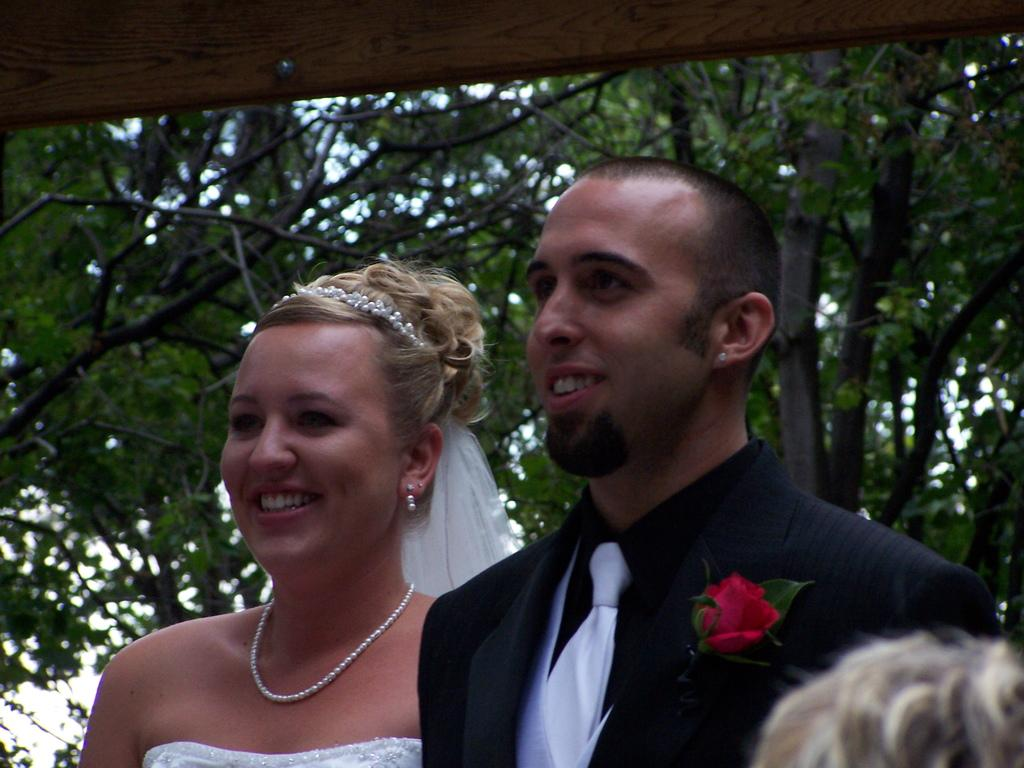What is located in the foreground of the image? There are people in the foreground of the image. What can be seen in the background of the image? There are trees in the background of the image. What is the tall, vertical object at the top of the image? There is a wooden pole at the top of the image. What type of cake is being taught in the cave in the image? There is no cake or teaching activity present in the image, nor is there a cave depicted. 